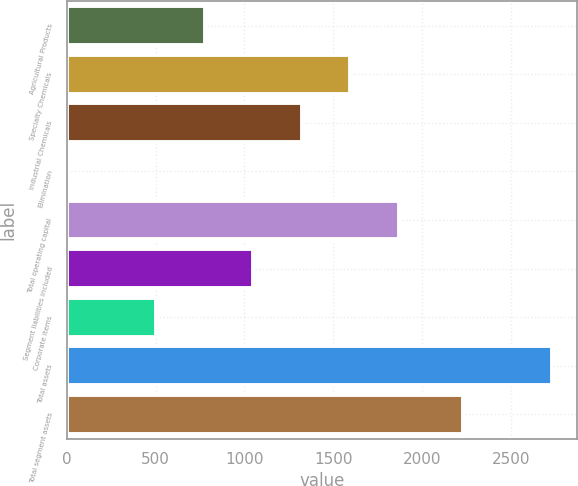Convert chart to OTSL. <chart><loc_0><loc_0><loc_500><loc_500><bar_chart><fcel>Agricultural Products<fcel>Specialty Chemicals<fcel>Industrial Chemicals<fcel>Elimination<fcel>Total operating capital<fcel>Segment liabilities included<fcel>Corporate items<fcel>Total assets<fcel>Total segment assets<nl><fcel>776.87<fcel>1597.28<fcel>1323.81<fcel>0.3<fcel>1870.75<fcel>1050.34<fcel>503.4<fcel>2735<fcel>2231.6<nl></chart> 